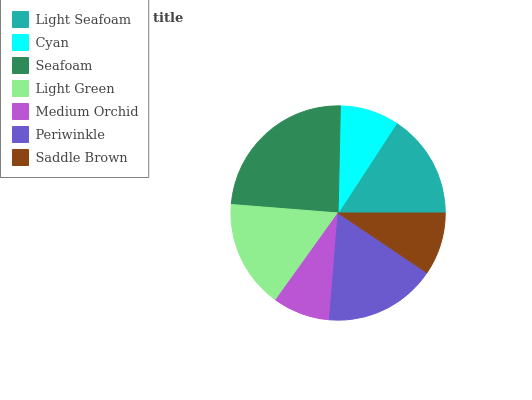Is Medium Orchid the minimum?
Answer yes or no. Yes. Is Seafoam the maximum?
Answer yes or no. Yes. Is Cyan the minimum?
Answer yes or no. No. Is Cyan the maximum?
Answer yes or no. No. Is Light Seafoam greater than Cyan?
Answer yes or no. Yes. Is Cyan less than Light Seafoam?
Answer yes or no. Yes. Is Cyan greater than Light Seafoam?
Answer yes or no. No. Is Light Seafoam less than Cyan?
Answer yes or no. No. Is Light Seafoam the high median?
Answer yes or no. Yes. Is Light Seafoam the low median?
Answer yes or no. Yes. Is Medium Orchid the high median?
Answer yes or no. No. Is Medium Orchid the low median?
Answer yes or no. No. 